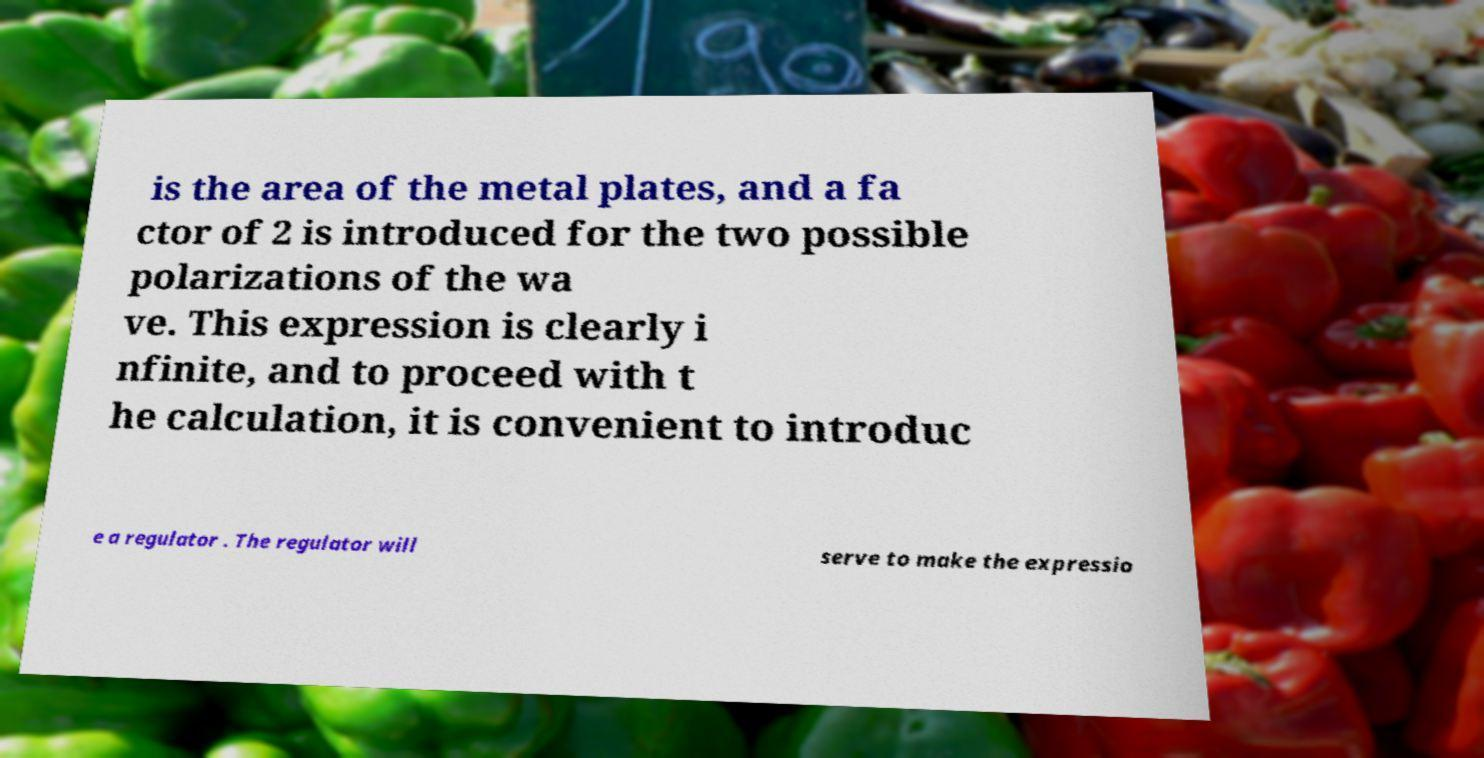What messages or text are displayed in this image? I need them in a readable, typed format. is the area of the metal plates, and a fa ctor of 2 is introduced for the two possible polarizations of the wa ve. This expression is clearly i nfinite, and to proceed with t he calculation, it is convenient to introduc e a regulator . The regulator will serve to make the expressio 